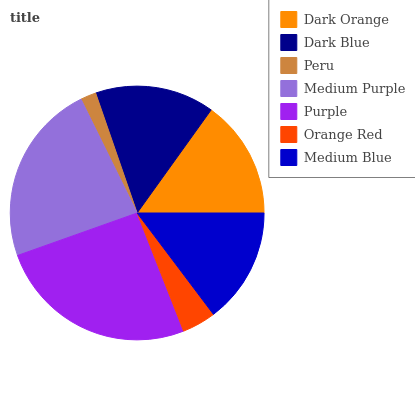Is Peru the minimum?
Answer yes or no. Yes. Is Purple the maximum?
Answer yes or no. Yes. Is Dark Blue the minimum?
Answer yes or no. No. Is Dark Blue the maximum?
Answer yes or no. No. Is Dark Blue greater than Dark Orange?
Answer yes or no. Yes. Is Dark Orange less than Dark Blue?
Answer yes or no. Yes. Is Dark Orange greater than Dark Blue?
Answer yes or no. No. Is Dark Blue less than Dark Orange?
Answer yes or no. No. Is Dark Orange the high median?
Answer yes or no. Yes. Is Dark Orange the low median?
Answer yes or no. Yes. Is Dark Blue the high median?
Answer yes or no. No. Is Peru the low median?
Answer yes or no. No. 